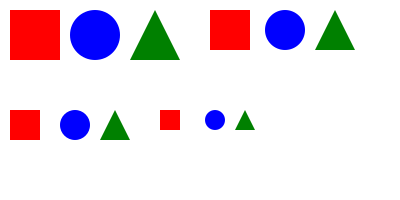In the given pattern of geometric shapes, what is the most likely ratio of the area of the red square to the area of the blue circle in the next iteration, assuming the trend continues? To solve this problem, we need to analyze the pattern in the series of shapes:

1. Observe that there are four iterations of the pattern, each with a red square, blue circle, and green triangle.

2. Focus on the red square and blue circle in each iteration:
   - 1st iteration: Square side ≈ 50, Circle radius ≈ 25
   - 2nd iteration: Square side ≈ 40, Circle radius ≈ 20
   - 3rd iteration: Square side ≈ 30, Circle radius ≈ 15
   - 4th iteration: Square side ≈ 20, Circle radius ≈ 10

3. Calculate the ratio of square area to circle area for each iteration:
   - 1st: $\frac{50^2}{\pi 25^2} \approx 1.27$
   - 2nd: $\frac{40^2}{\pi 20^2} \approx 1.27$
   - 3rd: $\frac{30^2}{\pi 15^2} \approx 1.27$
   - 4th: $\frac{20^2}{\pi 10^2} \approx 1.27$

4. Notice that the ratio remains constant at approximately 1.27 or $\frac{4}{\pi}$.

5. Assuming the trend continues, the next iteration would maintain this ratio.

Therefore, the most likely ratio of the area of the red square to the area of the blue circle in the next iteration would be $\frac{4}{\pi}$.
Answer: $\frac{4}{\pi}$ 